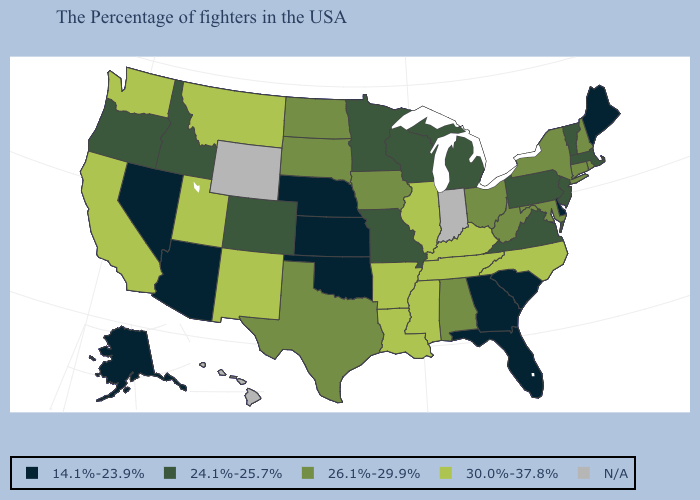Name the states that have a value in the range 14.1%-23.9%?
Keep it brief. Maine, Delaware, South Carolina, Florida, Georgia, Kansas, Nebraska, Oklahoma, Arizona, Nevada, Alaska. Among the states that border Alabama , does Florida have the lowest value?
Quick response, please. Yes. Name the states that have a value in the range 24.1%-25.7%?
Give a very brief answer. Massachusetts, Vermont, New Jersey, Pennsylvania, Virginia, Michigan, Wisconsin, Missouri, Minnesota, Colorado, Idaho, Oregon. What is the value of New Mexico?
Short answer required. 30.0%-37.8%. Does Kentucky have the highest value in the South?
Answer briefly. Yes. Which states have the lowest value in the South?
Keep it brief. Delaware, South Carolina, Florida, Georgia, Oklahoma. What is the highest value in the USA?
Give a very brief answer. 30.0%-37.8%. How many symbols are there in the legend?
Concise answer only. 5. Does Idaho have the highest value in the West?
Give a very brief answer. No. What is the value of Missouri?
Write a very short answer. 24.1%-25.7%. Does the first symbol in the legend represent the smallest category?
Give a very brief answer. Yes. What is the highest value in the Northeast ?
Write a very short answer. 26.1%-29.9%. What is the highest value in the West ?
Answer briefly. 30.0%-37.8%. 